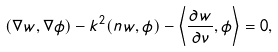<formula> <loc_0><loc_0><loc_500><loc_500>( \nabla w , \nabla \phi ) - k ^ { 2 } ( n w , \phi ) - \left \langle \frac { \partial w } { \partial \nu } , \phi \right \rangle = 0 ,</formula> 